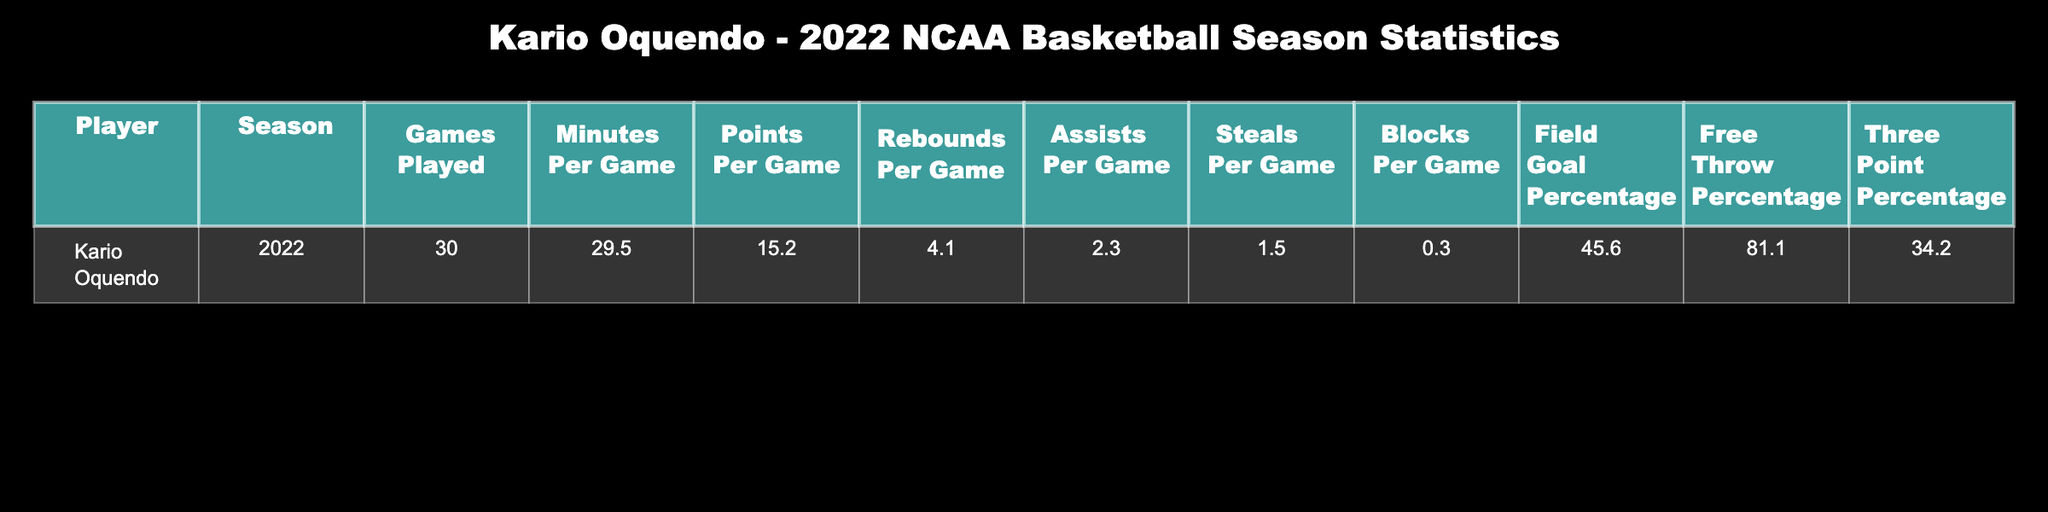What is Kario Oquendo's average points per game? From the table, the value under "Points Per Game" for Kario Oquendo is 15.2, which directly provides the answer.
Answer: 15.2 How many games did Kario Oquendo play during the 2022 NCAA season? The table indicates that Kario Oquendo played a total of 30 games in the season, which is a direct retrieval from the data.
Answer: 30 What is Kario Oquendo's free throw percentage? The "Free Throw Percentage" column shows that Kario Oquendo had a free throw percentage of 81.1, which can be taken directly from the table.
Answer: 81.1 Calculate the total rebounds Kario Oquendo had during the season. To find the total rebounds, multiply the number of games played (30) by the average rebounds per game (4.1). Thus, 30 * 4.1 = 123 total rebounds for the season.
Answer: 123 Did Kario Oquendo have more than 2 assists per game? According to the table, Kario Oquendo had an average of 2.3 assists per game, which is indeed greater than 2. Therefore, the answer is yes.
Answer: Yes What is the difference between Kario Oquendo's field goal percentage and three-point percentage? The field goal percentage is 45.6, and the three-point percentage is 34.2. The difference is calculated as 45.6 - 34.2 = 11.4. This calculation shows that he had a higher field goal percentage by 11.4.
Answer: 11.4 What percentage of minutes did Kario Oquendo average per game compared to the total available minutes in a 40-minute game? Kario Oquendo played an average of 29.5 minutes per game. To find the percentage of total minutes (40), we calculate (29.5 / 40) * 100 = 73.75%. This means he averaged approximately 73.75% of the total game time.
Answer: 73.75% How many blocks did Kario Oquendo average over the season? The table states that he had an average of 0.3 blocks per game. Since this is a direct retrieval from the data, the answer is straight from the entry.
Answer: 0.3 What is the ratio of steals to assists for Kario Oquendo? The table shows that Kario Oquendo had 1.5 steals and 2.3 assists. To find the ratio, we divide the steals by assists: 1.5 / 2.3 = approximately 0.652. This indicates that for every assist, he had about 0.652 steals.
Answer: 0.652 